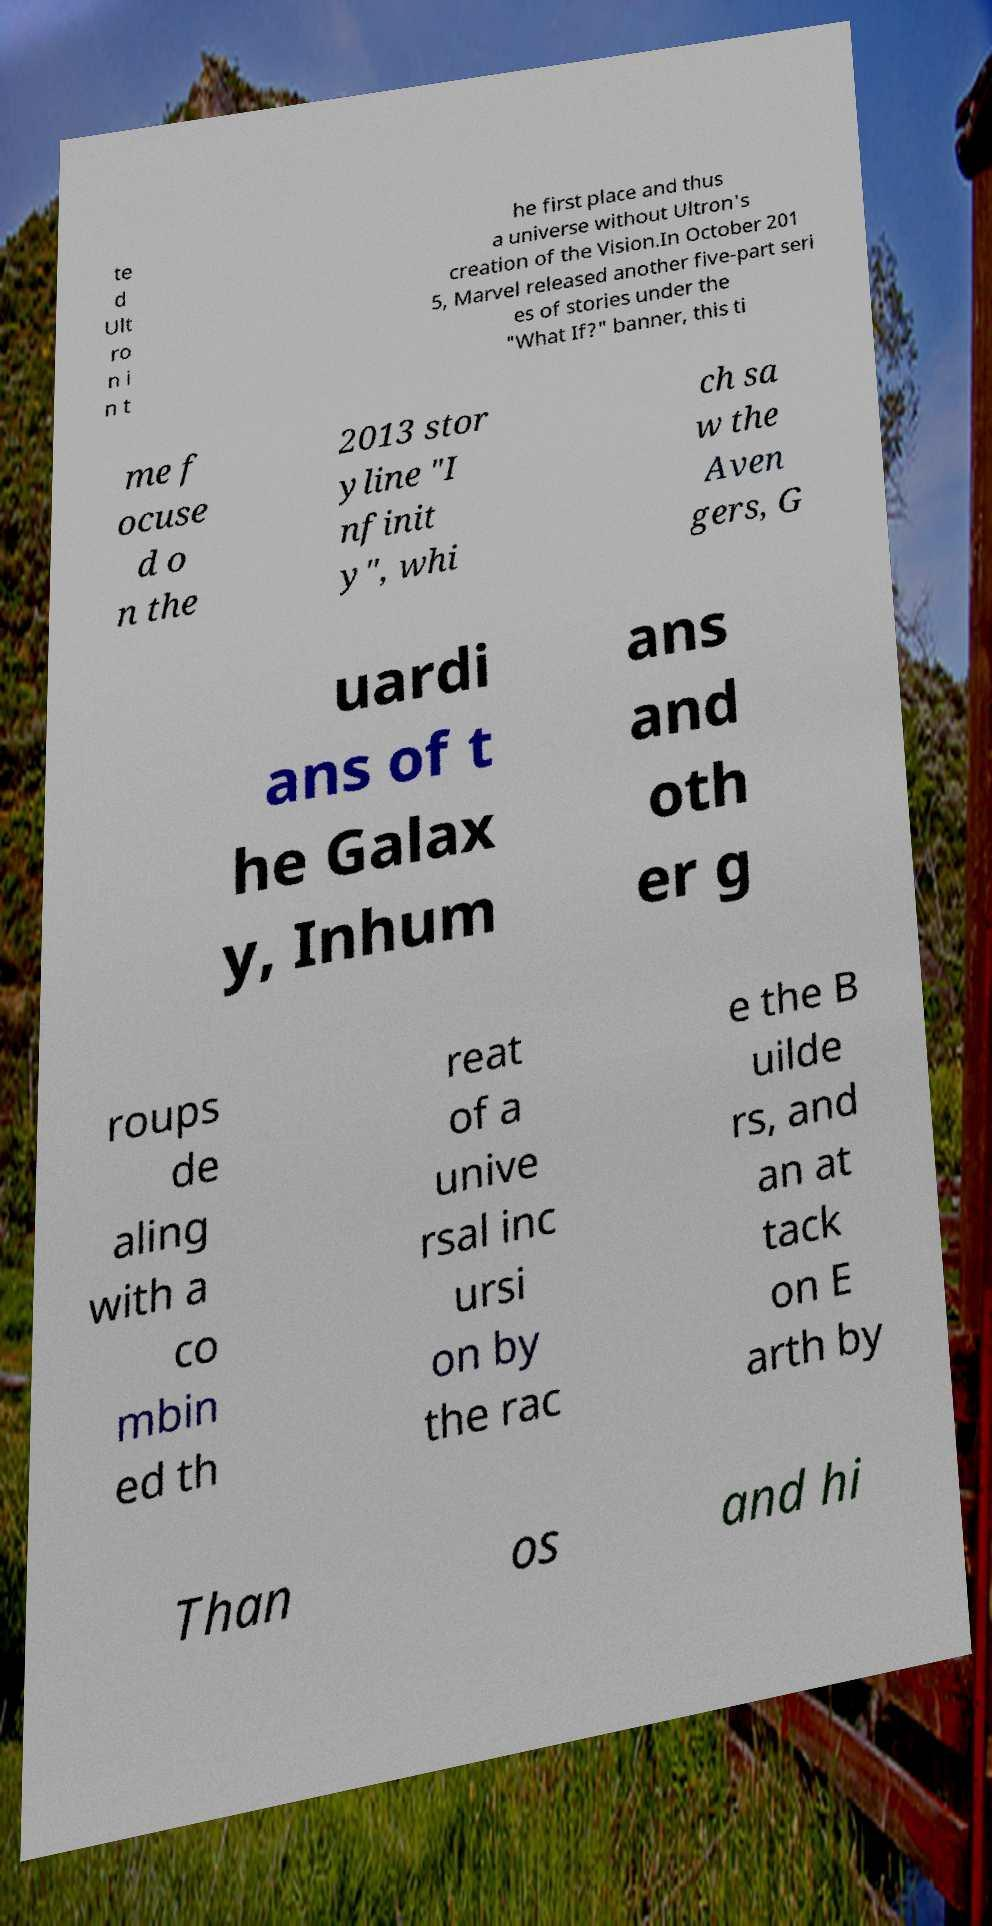What messages or text are displayed in this image? I need them in a readable, typed format. te d Ult ro n i n t he first place and thus a universe without Ultron's creation of the Vision.In October 201 5, Marvel released another five-part seri es of stories under the "What If?" banner, this ti me f ocuse d o n the 2013 stor yline "I nfinit y", whi ch sa w the Aven gers, G uardi ans of t he Galax y, Inhum ans and oth er g roups de aling with a co mbin ed th reat of a unive rsal inc ursi on by the rac e the B uilde rs, and an at tack on E arth by Than os and hi 